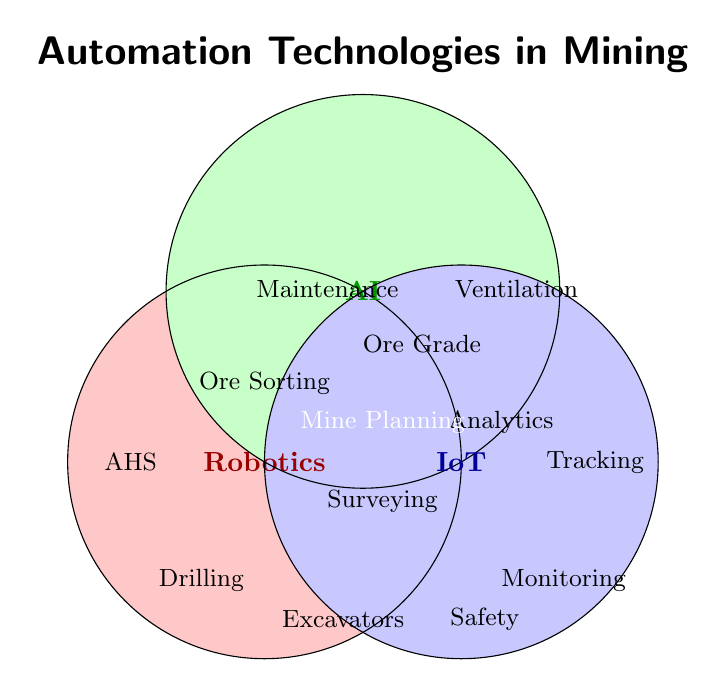Which technologies are shared between Robotics and AI? The technologies shared between Robotics and AI are located in the overlapping region between the Robotics and AI circles in the Venn diagram. This area is labeled with "Automated Ore Sorting."
Answer: Automated Ore Sorting How many total technologies are listed in all categories combined? Count all the technologies within the Venn diagram, including the individual and overlapping regions.
Answer: 13 Which technology is exclusively found in the intersection of Robotics, AI, and IoT? Identify the technology in the overlapping section of Robotics, AI, and IoT circles. It's labeled within the intersection area.
Answer: Autonomous Mine Planning List the technologies associated with IoT. Check the IoT circle and its overlapping sections with Robotics and AI. The technologies are "Equipment Tracking," "Environmental Monitoring," "Worker Safety Sensors," "Drone Surveying" (with Robotics), "Real-time Production Analytics" (with AI), and "Autonomous Mine Planning" (with Robotics and AI).
Answer: Equipment Tracking, Environmental Monitoring, Worker Safety Sensors, Drone Surveying, Real-time Production Analytics, Autonomous Mine Planning Which category has the fewest unique technologies, and what are they? Compare the unique technologies in each circle that are not part of any overlap. Robotics has 3, AI has 3, and IoT has 3 unique technologies each. This makes them all equal in the number of unique technologies.
Answer: Robotics, AI, and IoT (all equal) What is the common technology between AI and IoT, but not Robotics? Locate the section where AI and IoT overlap without including Robotics. It's labeled "Real-time Production Analytics."
Answer: Real-time Production Analytics How many technologies are shared between exactly two categories? Identify the technologies in regions where only two circles overlap. The pairs are "Automated Ore Sorting" (Robotics/AI), "Drone Surveying" (Robotics/IoT), and "Real-time Production Analytics" (AI/IoT).
Answer: 3 Which category has the most unique technologies, and how many are there? Count the unique technologies in each category. All categories (Robotics, AI, and IoT) have an equal count of 3 unique technologies each.
Answer: All categories have 3 What are the technologies exclusive to Robotics? Locate the unique technologies within the Robotics circle that do not overlap with AI or IoT. They are "Autonomous Haulage Systems," "Robotic Drilling," and "Remote-Controlled Excavators."
Answer: Autonomous Haulage Systems, Robotic Drilling, Remote-Controlled Excavators 